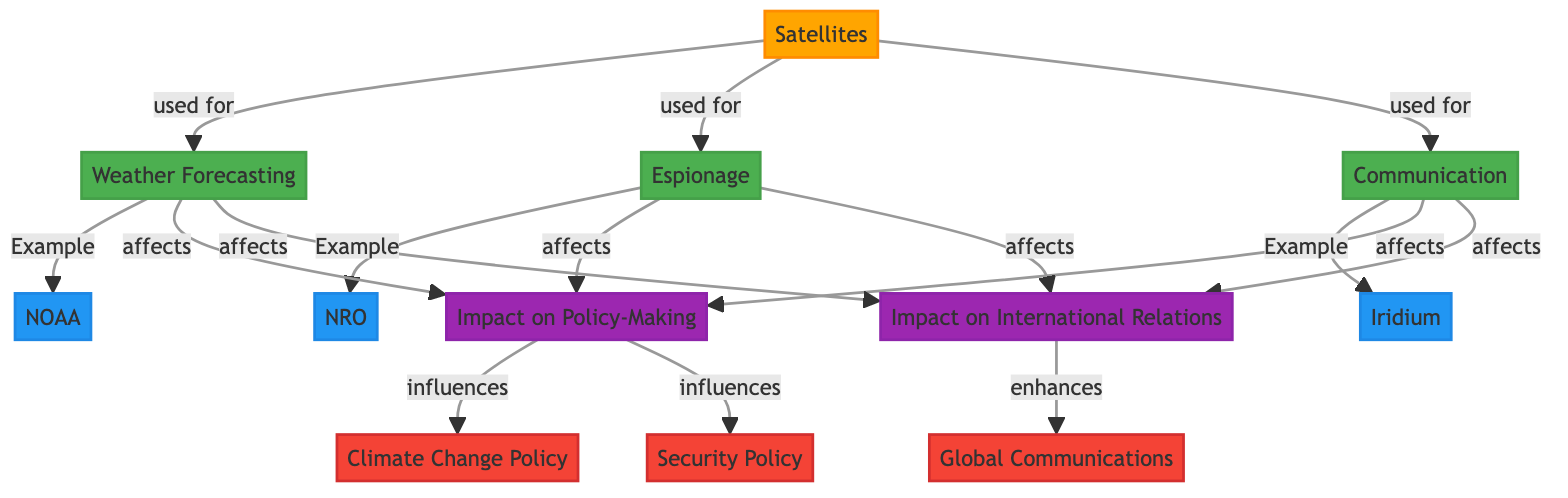What are the three main uses of satellites depicted in the diagram? The diagram shows three main uses of satellites: Weather Forecasting, Espionage, and Communication. These nodes are directly connected to the central node of Satellites, indicating their primary functions.
Answer: Weather Forecasting, Espionage, Communication Which example corresponds to Weather Forecasting? In the diagram, the example that corresponds to Weather Forecasting is NOAA, as it is connected to the Weather Forecasting node with the label "Example."
Answer: NOAA How does Espionage affect Policy-Making according to the diagram? The diagram indicates that Espionage affects Impact on Policy-Making, which is directly connected. This means that activities associated with espionage have implications for policy decisions.
Answer: It affects Impact on Policy-Making What is the relationship between Communication and International Relations? The diagram illustrates that Communication affects Impact on International Relations, as indicated by the edge connecting these two nodes. Thus, communication can influence international diplomatic relations.
Answer: It affects Impact on International Relations What influences Climate Change Policy as shown in the diagram? The diagram points out that Impact on Policy-Making influences Climate Change Policy. This conveys that decisions made in policy-making carry direct consequences for climate policies.
Answer: Impact on Policy-Making 